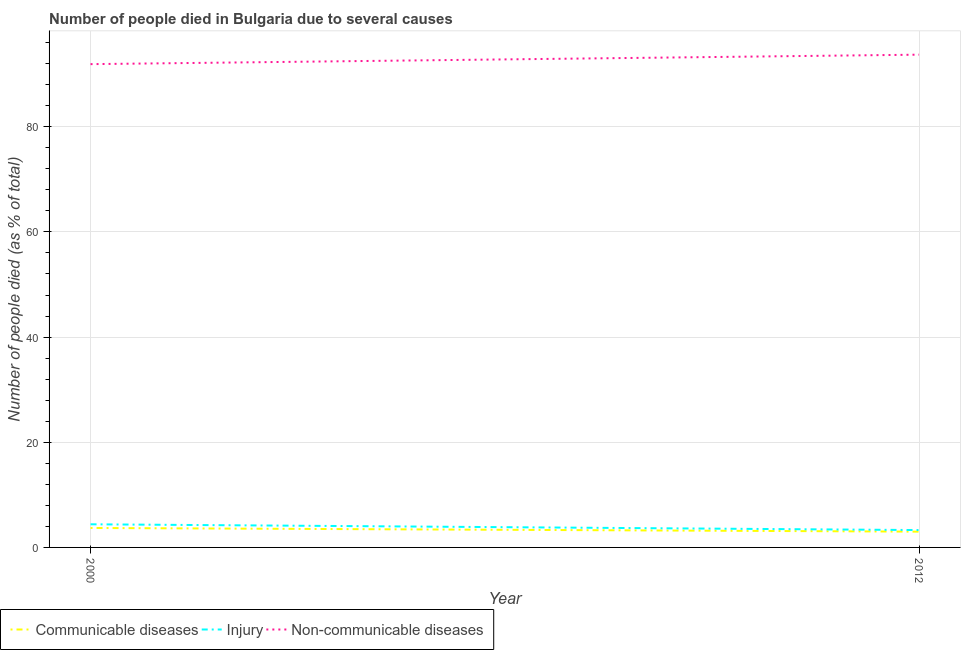Does the line corresponding to number of people who died of communicable diseases intersect with the line corresponding to number of people who dies of non-communicable diseases?
Give a very brief answer. No. Is the number of lines equal to the number of legend labels?
Offer a very short reply. Yes. What is the number of people who dies of non-communicable diseases in 2000?
Your answer should be compact. 91.9. Across all years, what is the minimum number of people who dies of non-communicable diseases?
Provide a short and direct response. 91.9. In which year was the number of people who dies of non-communicable diseases minimum?
Ensure brevity in your answer.  2000. What is the total number of people who died of injury in the graph?
Provide a short and direct response. 7.7. What is the difference between the number of people who died of communicable diseases in 2000 and that in 2012?
Your response must be concise. 0.7. What is the difference between the number of people who died of injury in 2012 and the number of people who died of communicable diseases in 2000?
Give a very brief answer. -0.4. What is the average number of people who dies of non-communicable diseases per year?
Provide a short and direct response. 92.8. In the year 2012, what is the difference between the number of people who died of communicable diseases and number of people who died of injury?
Make the answer very short. -0.3. In how many years, is the number of people who died of injury greater than 84 %?
Your response must be concise. 0. What is the ratio of the number of people who died of injury in 2000 to that in 2012?
Provide a succinct answer. 1.33. Is the number of people who died of injury in 2000 less than that in 2012?
Offer a terse response. No. In how many years, is the number of people who died of injury greater than the average number of people who died of injury taken over all years?
Offer a terse response. 1. Does the number of people who dies of non-communicable diseases monotonically increase over the years?
Make the answer very short. Yes. Is the number of people who dies of non-communicable diseases strictly greater than the number of people who died of communicable diseases over the years?
Offer a very short reply. Yes. Is the number of people who died of communicable diseases strictly less than the number of people who died of injury over the years?
Keep it short and to the point. Yes. How many lines are there?
Your response must be concise. 3. How many years are there in the graph?
Offer a terse response. 2. How many legend labels are there?
Your response must be concise. 3. How are the legend labels stacked?
Give a very brief answer. Horizontal. What is the title of the graph?
Give a very brief answer. Number of people died in Bulgaria due to several causes. What is the label or title of the X-axis?
Offer a very short reply. Year. What is the label or title of the Y-axis?
Keep it short and to the point. Number of people died (as % of total). What is the Number of people died (as % of total) in Communicable diseases in 2000?
Provide a succinct answer. 3.7. What is the Number of people died (as % of total) in Injury in 2000?
Provide a short and direct response. 4.4. What is the Number of people died (as % of total) in Non-communicable diseases in 2000?
Offer a very short reply. 91.9. What is the Number of people died (as % of total) in Non-communicable diseases in 2012?
Your response must be concise. 93.7. Across all years, what is the maximum Number of people died (as % of total) of Injury?
Give a very brief answer. 4.4. Across all years, what is the maximum Number of people died (as % of total) in Non-communicable diseases?
Offer a very short reply. 93.7. Across all years, what is the minimum Number of people died (as % of total) of Non-communicable diseases?
Provide a short and direct response. 91.9. What is the total Number of people died (as % of total) in Injury in the graph?
Your answer should be compact. 7.7. What is the total Number of people died (as % of total) of Non-communicable diseases in the graph?
Your answer should be very brief. 185.6. What is the difference between the Number of people died (as % of total) of Communicable diseases in 2000 and that in 2012?
Your answer should be compact. 0.7. What is the difference between the Number of people died (as % of total) in Non-communicable diseases in 2000 and that in 2012?
Your answer should be very brief. -1.8. What is the difference between the Number of people died (as % of total) in Communicable diseases in 2000 and the Number of people died (as % of total) in Injury in 2012?
Your answer should be compact. 0.4. What is the difference between the Number of people died (as % of total) of Communicable diseases in 2000 and the Number of people died (as % of total) of Non-communicable diseases in 2012?
Offer a very short reply. -90. What is the difference between the Number of people died (as % of total) of Injury in 2000 and the Number of people died (as % of total) of Non-communicable diseases in 2012?
Your response must be concise. -89.3. What is the average Number of people died (as % of total) in Communicable diseases per year?
Offer a terse response. 3.35. What is the average Number of people died (as % of total) of Injury per year?
Keep it short and to the point. 3.85. What is the average Number of people died (as % of total) in Non-communicable diseases per year?
Keep it short and to the point. 92.8. In the year 2000, what is the difference between the Number of people died (as % of total) of Communicable diseases and Number of people died (as % of total) of Injury?
Your response must be concise. -0.7. In the year 2000, what is the difference between the Number of people died (as % of total) of Communicable diseases and Number of people died (as % of total) of Non-communicable diseases?
Offer a very short reply. -88.2. In the year 2000, what is the difference between the Number of people died (as % of total) of Injury and Number of people died (as % of total) of Non-communicable diseases?
Provide a short and direct response. -87.5. In the year 2012, what is the difference between the Number of people died (as % of total) of Communicable diseases and Number of people died (as % of total) of Non-communicable diseases?
Your response must be concise. -90.7. In the year 2012, what is the difference between the Number of people died (as % of total) of Injury and Number of people died (as % of total) of Non-communicable diseases?
Give a very brief answer. -90.4. What is the ratio of the Number of people died (as % of total) of Communicable diseases in 2000 to that in 2012?
Your response must be concise. 1.23. What is the ratio of the Number of people died (as % of total) of Injury in 2000 to that in 2012?
Give a very brief answer. 1.33. What is the ratio of the Number of people died (as % of total) of Non-communicable diseases in 2000 to that in 2012?
Provide a succinct answer. 0.98. What is the difference between the highest and the second highest Number of people died (as % of total) in Non-communicable diseases?
Offer a terse response. 1.8. What is the difference between the highest and the lowest Number of people died (as % of total) in Injury?
Offer a terse response. 1.1. What is the difference between the highest and the lowest Number of people died (as % of total) of Non-communicable diseases?
Your answer should be very brief. 1.8. 